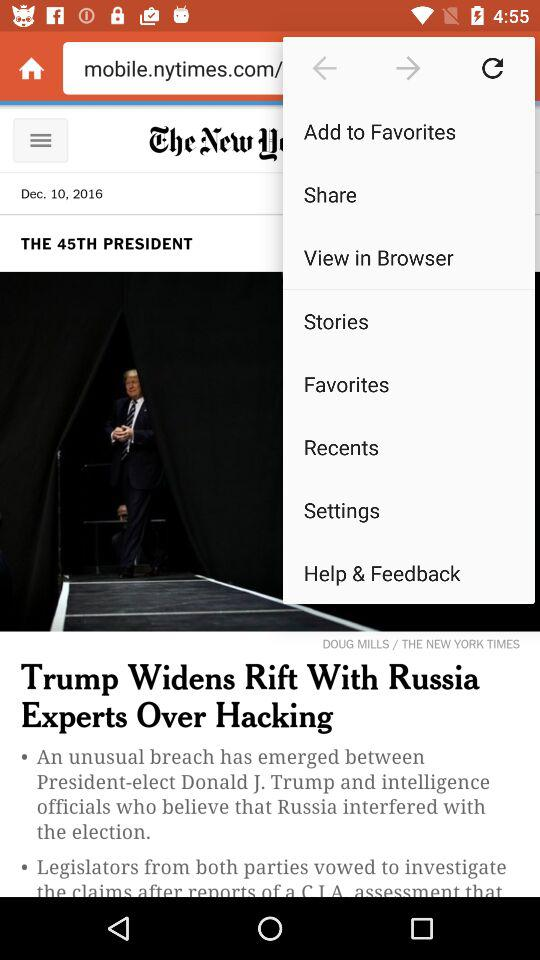Who served as the 45th President of the United States of America? The 45th President of the United States of America was Donald J. Trump. 